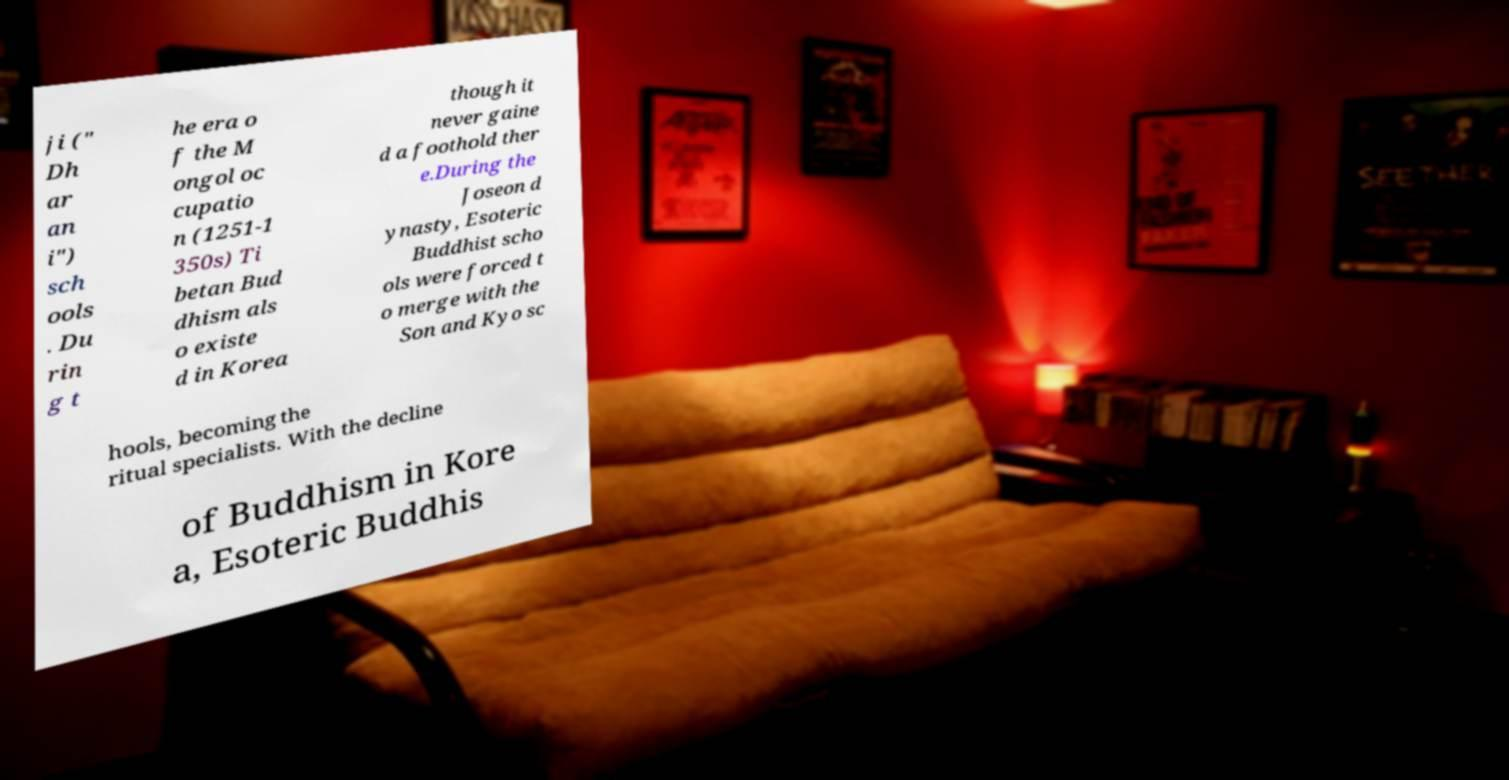Please identify and transcribe the text found in this image. ji (" Dh ar an i") sch ools . Du rin g t he era o f the M ongol oc cupatio n (1251-1 350s) Ti betan Bud dhism als o existe d in Korea though it never gaine d a foothold ther e.During the Joseon d ynasty, Esoteric Buddhist scho ols were forced t o merge with the Son and Kyo sc hools, becoming the ritual specialists. With the decline of Buddhism in Kore a, Esoteric Buddhis 